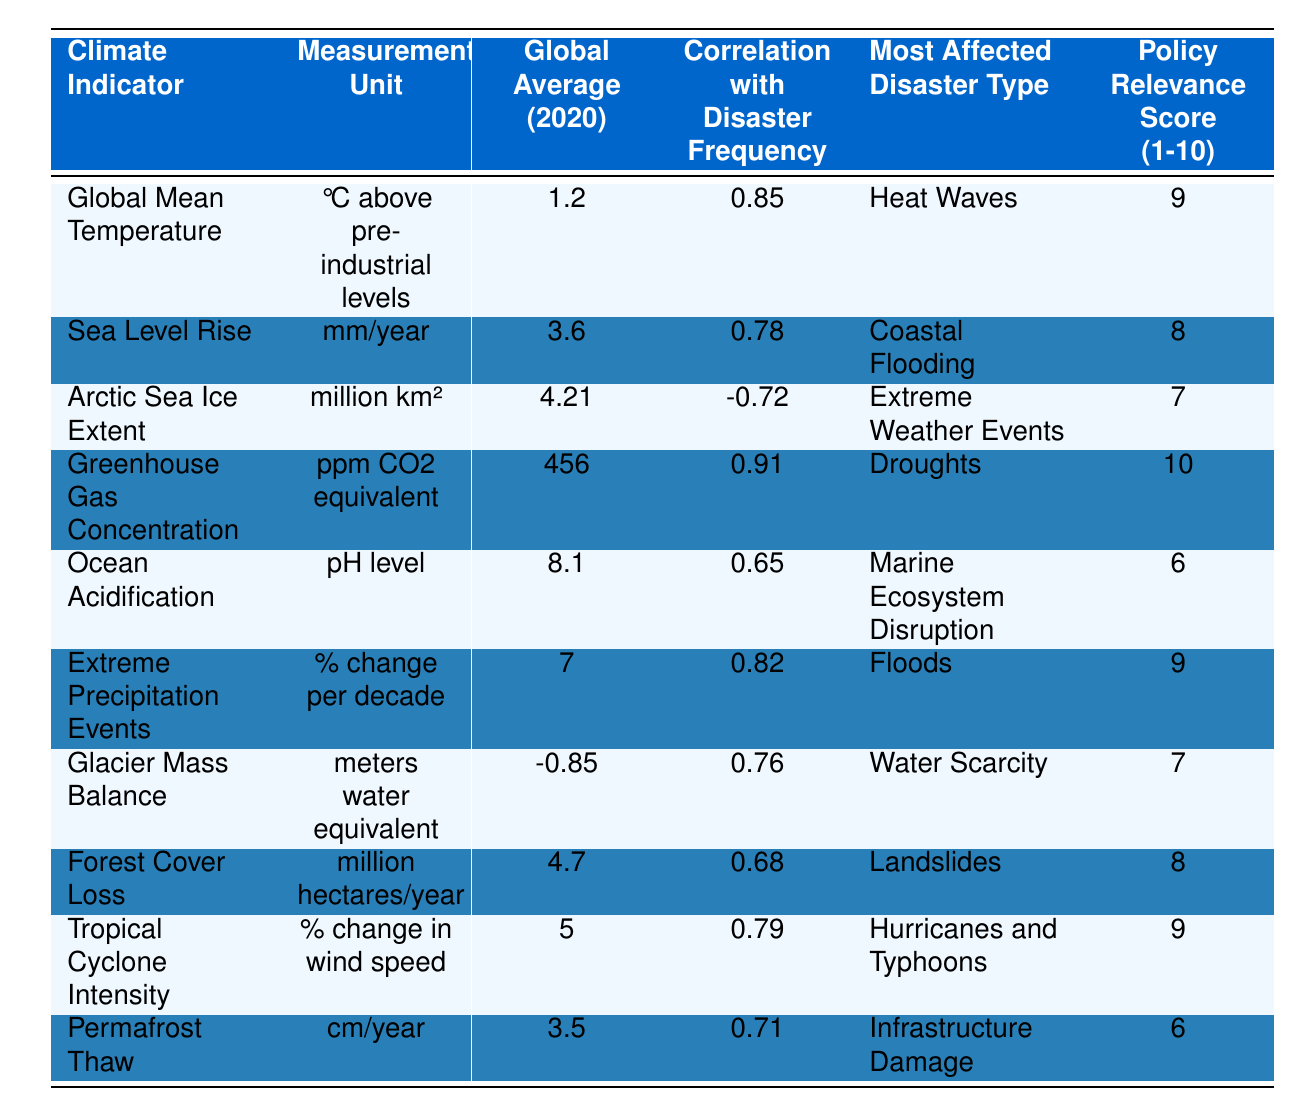What is the global average temperature in 2020? The table lists "Global Mean Temperature" under the "Global Average (2020)" column, where the value is 1.2 °C above pre-industrial levels.
Answer: 1.2 °C Which climate indicator has the highest correlation with disaster frequency? The "Correlation with Disaster Frequency" column indicates the highest value is 0.91 for "Greenhouse Gas Concentration."
Answer: Greenhouse Gas Concentration What is the policy relevance score for sea level rise? By examining the "Policy Relevance Score" for "Sea Level Rise," it is found to be 8.
Answer: 8 Is there a negative correlation for any of the climate indicators? The table shows "Arctic Sea Ice Extent" with a correlation of -0.72, indicating a negative correlation.
Answer: Yes What is the average correlation of the climate indicators with disaster frequency? The correlation values are 0.85, 0.78, -0.72, 0.91, 0.65, 0.82, 0.76, 0.68, 0.79, and 0.71. Summing these gives 5.68, and dividing by 10 gives an average of 0.568.
Answer: 0.568 Which disaster type is most affected by greenhouse gas concentration? The "Most Affected Disaster Type" for "Greenhouse Gas Concentration" is listed as "Droughts."
Answer: Droughts What is the change in extreme precipitation events? The value listed under "Extreme Precipitation Events" for "Global Average (2020)" is 7% change per decade.
Answer: 7% Which indicator correlates with both extreme weather events and has a positive score? "Forest Cover Loss" has a correlation of 0.68 and is associated with "Landslides," a type of extreme weather event.
Answer: Forest Cover Loss What is the most affected disaster type resulting from ocean acidification? The table states that the "Most Affected Disaster Type" for "Ocean Acidification" is "Marine Ecosystem Disruption."
Answer: Marine Ecosystem Disruption How many climate indicators have a policy relevance score of 9 or higher? The table indicates that "Global Mean Temperature," "Greenhouse Gas Concentration," "Extreme Precipitation Events," and "Tropical Cyclone Intensity" have scores of 9 or higher, totaling four indicators.
Answer: Four indicators 